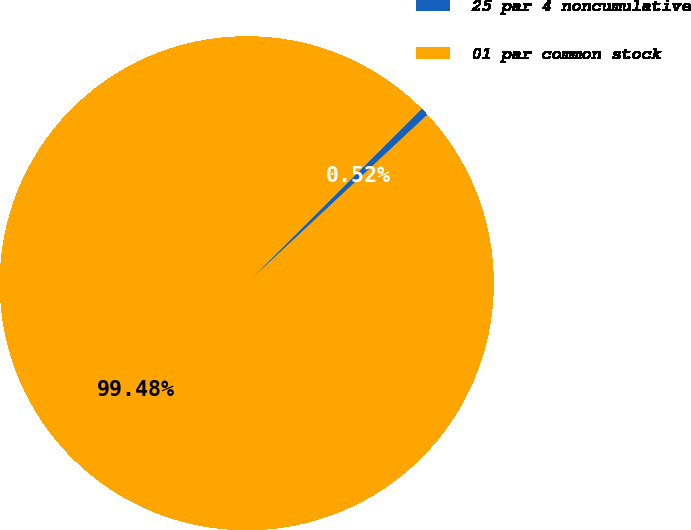Convert chart. <chart><loc_0><loc_0><loc_500><loc_500><pie_chart><fcel>25 par 4 noncumulative<fcel>01 par common stock<nl><fcel>0.52%<fcel>99.48%<nl></chart> 